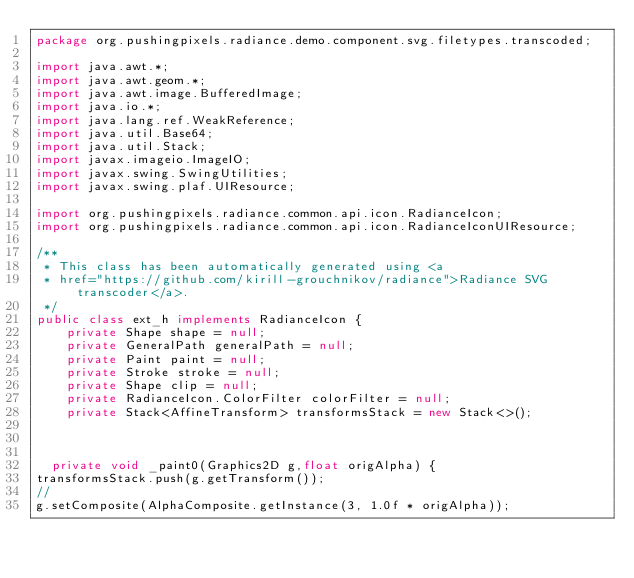<code> <loc_0><loc_0><loc_500><loc_500><_Java_>package org.pushingpixels.radiance.demo.component.svg.filetypes.transcoded;

import java.awt.*;
import java.awt.geom.*;
import java.awt.image.BufferedImage;
import java.io.*;
import java.lang.ref.WeakReference;
import java.util.Base64;
import java.util.Stack;
import javax.imageio.ImageIO;
import javax.swing.SwingUtilities;
import javax.swing.plaf.UIResource;

import org.pushingpixels.radiance.common.api.icon.RadianceIcon;
import org.pushingpixels.radiance.common.api.icon.RadianceIconUIResource;

/**
 * This class has been automatically generated using <a
 * href="https://github.com/kirill-grouchnikov/radiance">Radiance SVG transcoder</a>.
 */
public class ext_h implements RadianceIcon {
    private Shape shape = null;
    private GeneralPath generalPath = null;
    private Paint paint = null;
    private Stroke stroke = null;
    private Shape clip = null;
    private RadianceIcon.ColorFilter colorFilter = null;
    private Stack<AffineTransform> transformsStack = new Stack<>();

    

	private void _paint0(Graphics2D g,float origAlpha) {
transformsStack.push(g.getTransform());
// 
g.setComposite(AlphaComposite.getInstance(3, 1.0f * origAlpha));</code> 